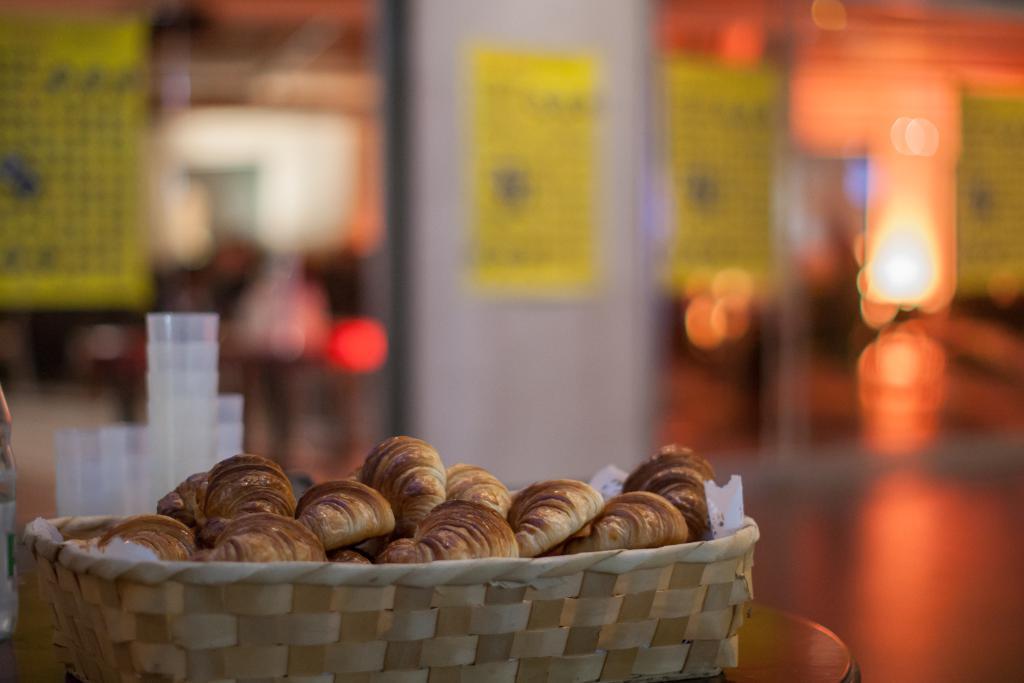Describe this image in one or two sentences. This picture seems to be clicked inside. In the foreground we can see a wooden table on the top of which a basket containing some food items is placed and the glasses and some other items are placed on the top of the table. The background of the image is blur and we can see the lights and some other objects. 